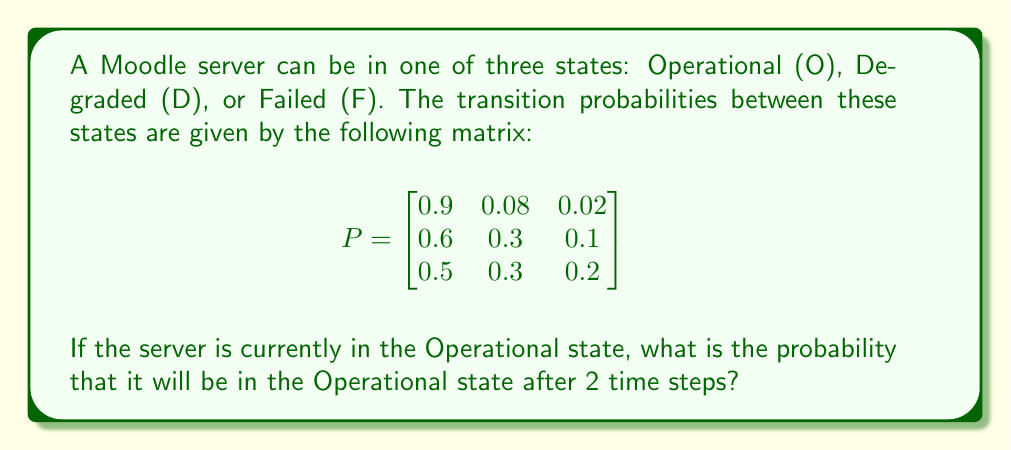Could you help me with this problem? To solve this problem, we'll use the Chapman-Kolmogorov equations and matrix multiplication:

1) The initial state vector is $\mathbf{v}_0 = [1, 0, 0]$ since the server starts in the Operational state.

2) We need to calculate $P^2$ (the transition matrix raised to the power of 2):

   $$P^2 = P \times P = \begin{bmatrix}
   0.9 & 0.08 & 0.02 \\
   0.6 & 0.3 & 0.1 \\
   0.5 & 0.3 & 0.2
   \end{bmatrix} \times \begin{bmatrix}
   0.9 & 0.08 & 0.02 \\
   0.6 & 0.3 & 0.1 \\
   0.5 & 0.3 & 0.2
   \end{bmatrix}$$

3) Performing the matrix multiplication:

   $$P^2 = \begin{bmatrix}
   0.846 & 0.1172 & 0.0368 \\
   0.78 & 0.1680 & 0.0520 \\
   0.75 & 0.1830 & 0.0670
   \end{bmatrix}$$

4) The probability of being in the Operational state after 2 time steps is given by the first element of $\mathbf{v}_0 \times P^2$:

   $$\mathbf{v}_0 \times P^2 = [1, 0, 0] \times \begin{bmatrix}
   0.846 & 0.1172 & 0.0368 \\
   0.78 & 0.1680 & 0.0520 \\
   0.75 & 0.1830 & 0.0670
   \end{bmatrix} = [0.846, 0.1172, 0.0368]$$

5) Therefore, the probability of being in the Operational state after 2 time steps is 0.846 or 84.6%.
Answer: 0.846 